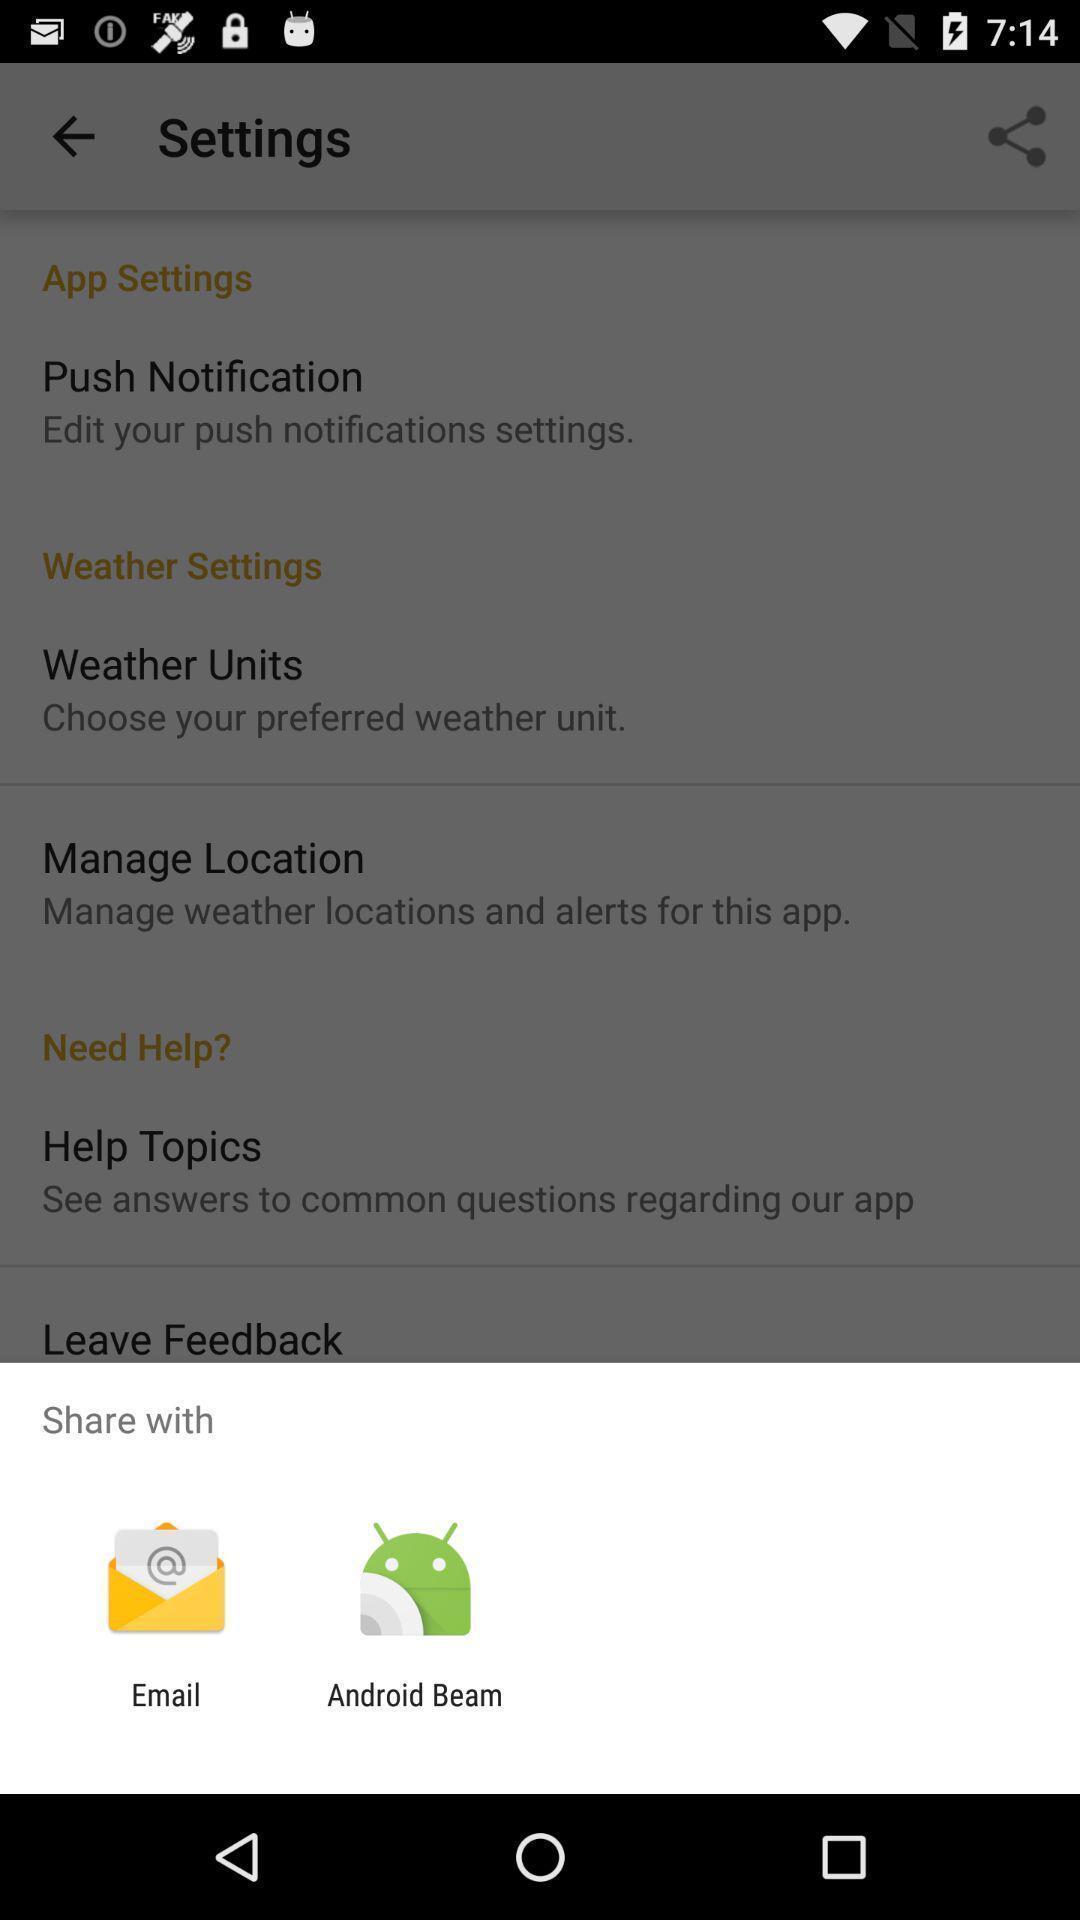Tell me what you see in this picture. Popup showing different apps to share. 